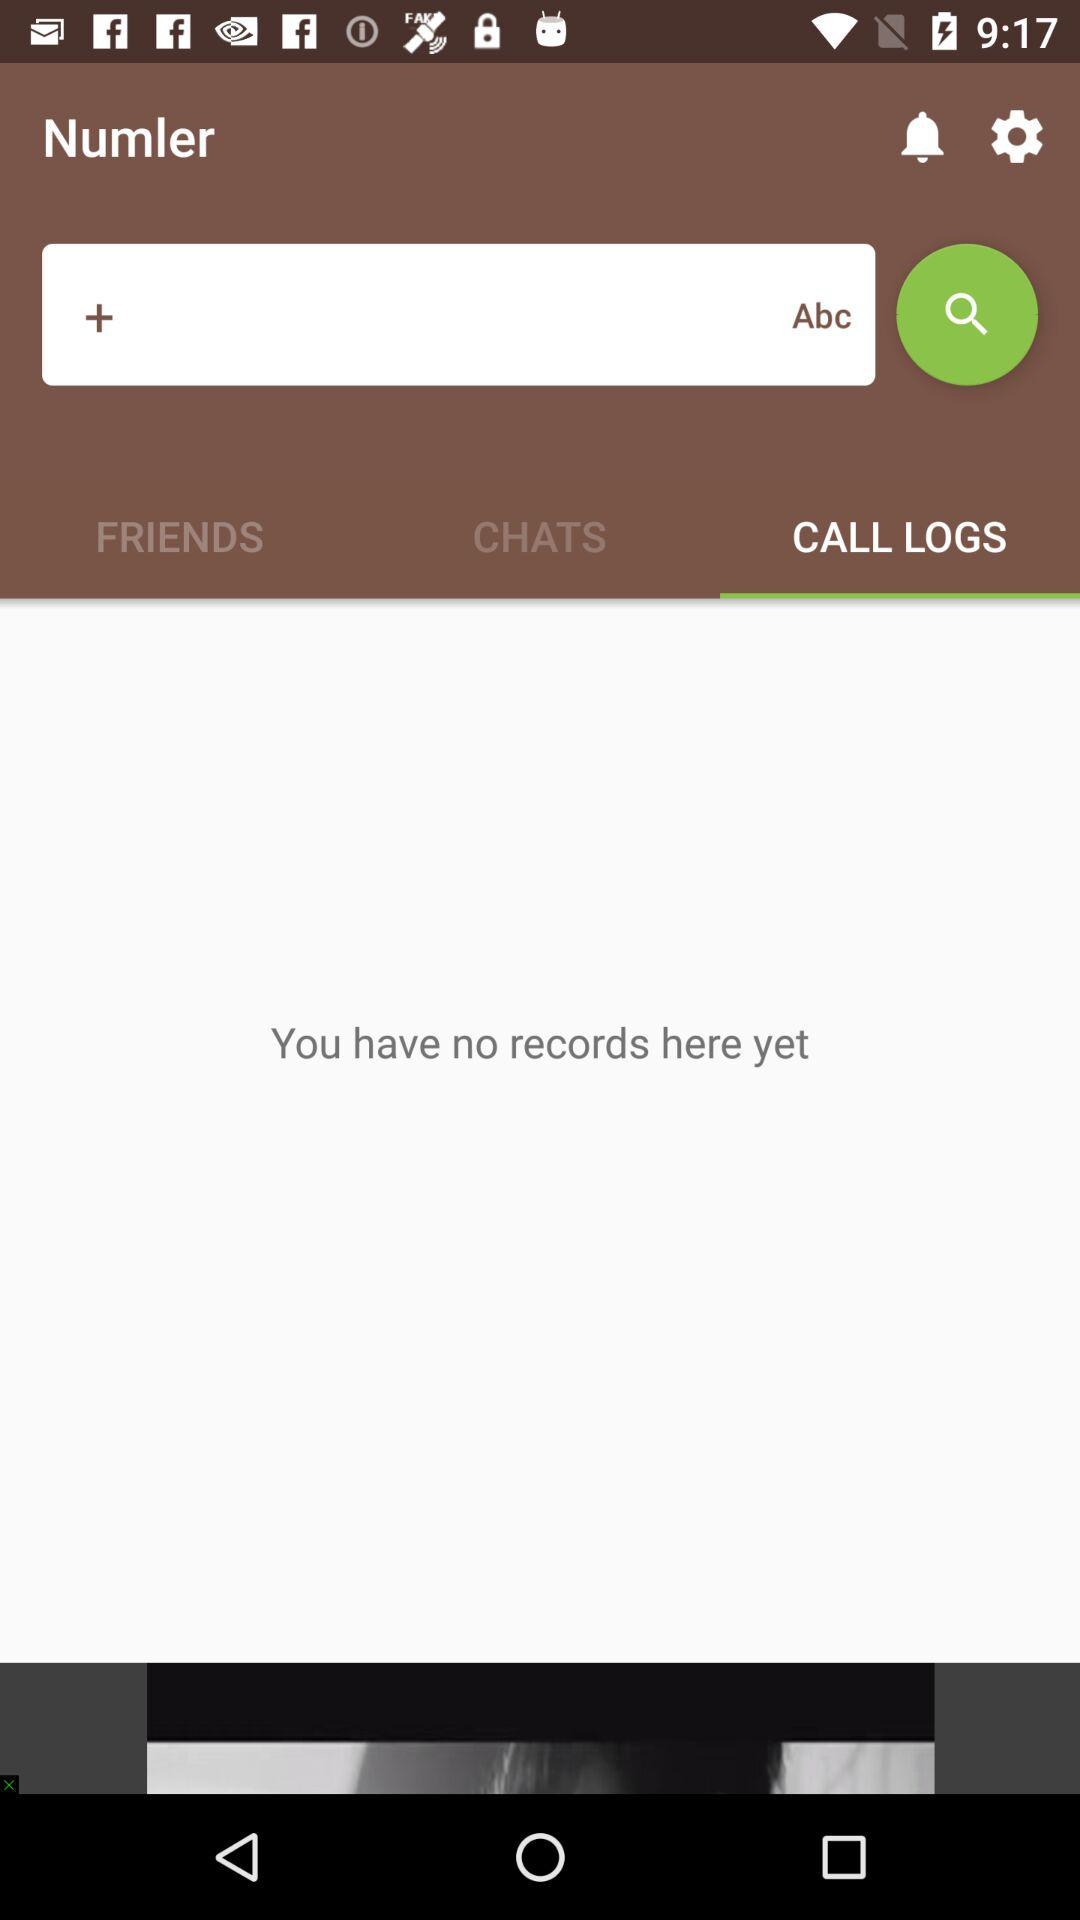Which tab is selected? The selected tab is "CALL LOGS". 